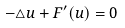<formula> <loc_0><loc_0><loc_500><loc_500>- \triangle u + F ^ { \prime } ( u ) = 0</formula> 